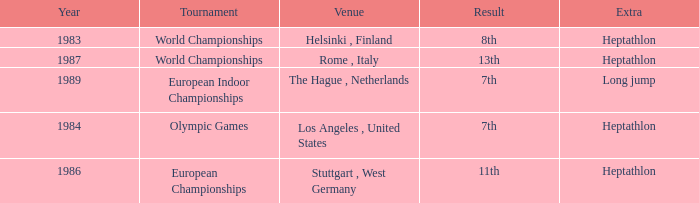Where was the 1984 Olympics hosted? Olympic Games. 